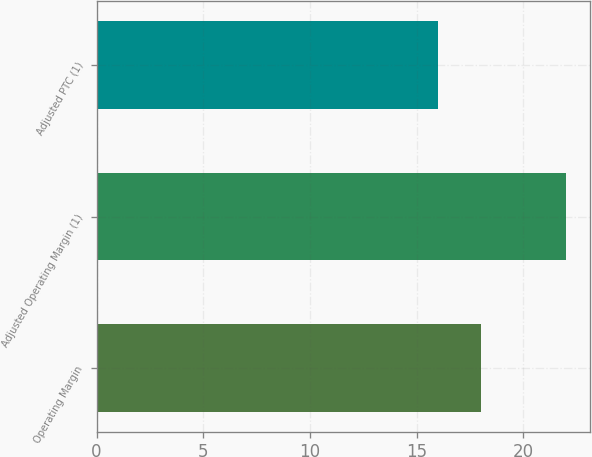Convert chart to OTSL. <chart><loc_0><loc_0><loc_500><loc_500><bar_chart><fcel>Operating Margin<fcel>Adjusted Operating Margin (1)<fcel>Adjusted PTC (1)<nl><fcel>18<fcel>22<fcel>16<nl></chart> 